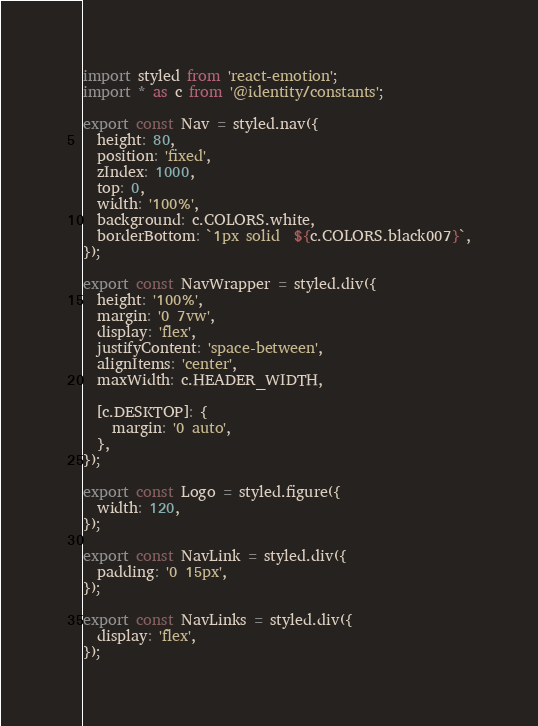Convert code to text. <code><loc_0><loc_0><loc_500><loc_500><_JavaScript_>import styled from 'react-emotion';
import * as c from '@identity/constants';

export const Nav = styled.nav({
  height: 80,
  position: 'fixed',
  zIndex: 1000,
  top: 0,
  width: '100%',
  background: c.COLORS.white,
  borderBottom: `1px solid  ${c.COLORS.black007}`,
});

export const NavWrapper = styled.div({
  height: '100%',
  margin: '0 7vw',
  display: 'flex',
  justifyContent: 'space-between',
  alignItems: 'center',
  maxWidth: c.HEADER_WIDTH,

  [c.DESKTOP]: {
    margin: '0 auto',
  },
});

export const Logo = styled.figure({
  width: 120,
});

export const NavLink = styled.div({
  padding: '0 15px',
});

export const NavLinks = styled.div({
  display: 'flex',
});
</code> 